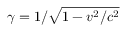Convert formula to latex. <formula><loc_0><loc_0><loc_500><loc_500>\gamma = 1 / \sqrt { 1 - v ^ { 2 } / c ^ { 2 } }</formula> 